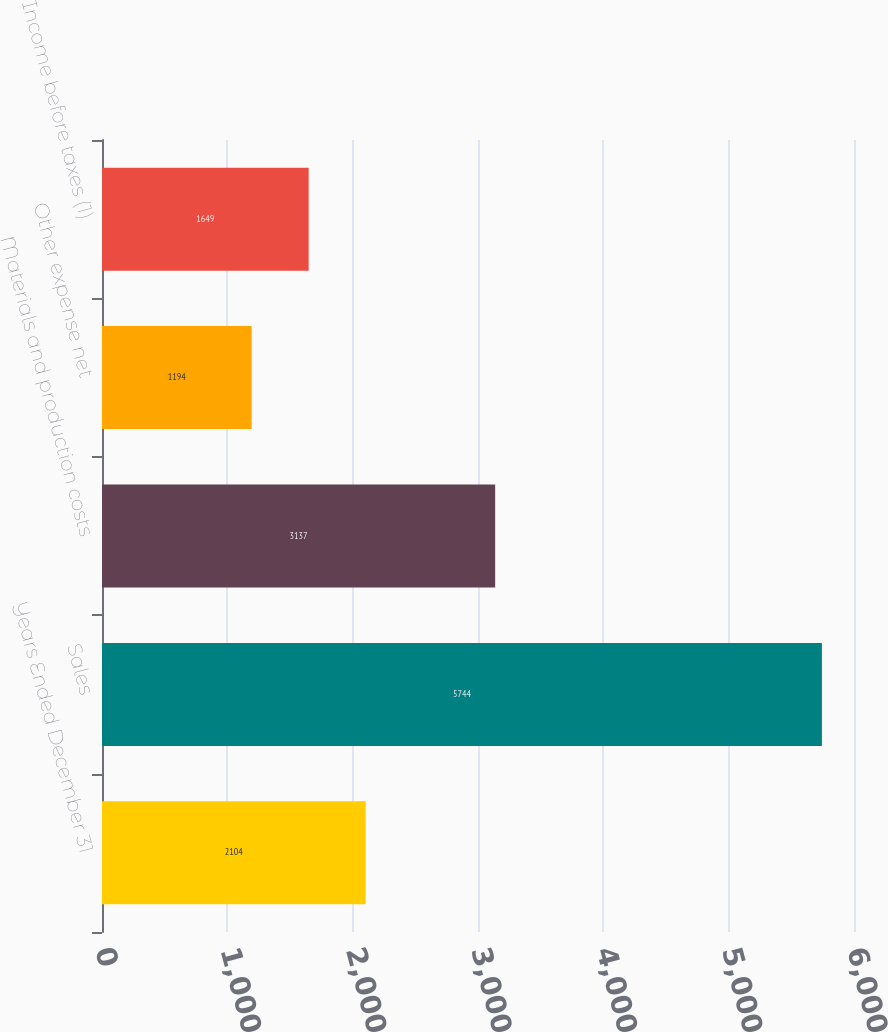<chart> <loc_0><loc_0><loc_500><loc_500><bar_chart><fcel>Years Ended December 31<fcel>Sales<fcel>Materials and production costs<fcel>Other expense net<fcel>Income before taxes (1)<nl><fcel>2104<fcel>5744<fcel>3137<fcel>1194<fcel>1649<nl></chart> 